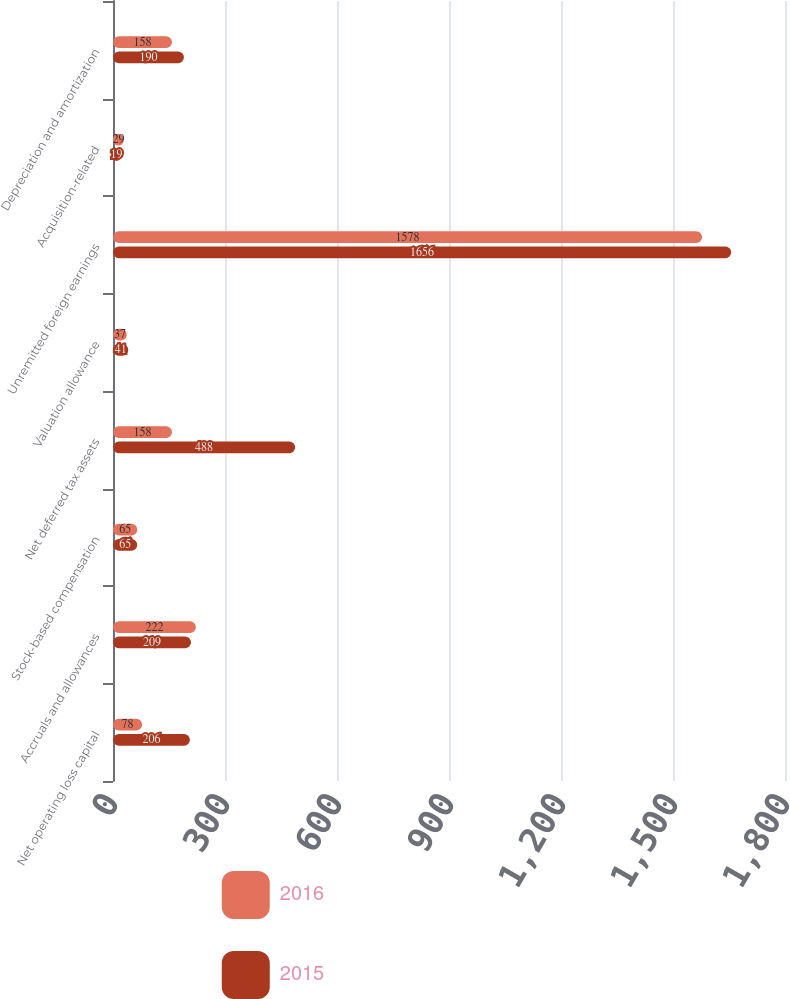<chart> <loc_0><loc_0><loc_500><loc_500><stacked_bar_chart><ecel><fcel>Net operating loss capital<fcel>Accruals and allowances<fcel>Stock-based compensation<fcel>Net deferred tax assets<fcel>Valuation allowance<fcel>Unremitted foreign earnings<fcel>Acquisition-related<fcel>Depreciation and amortization<nl><fcel>2016<fcel>78<fcel>222<fcel>65<fcel>158<fcel>37<fcel>1578<fcel>29<fcel>158<nl><fcel>2015<fcel>206<fcel>209<fcel>65<fcel>488<fcel>41<fcel>1656<fcel>19<fcel>190<nl></chart> 